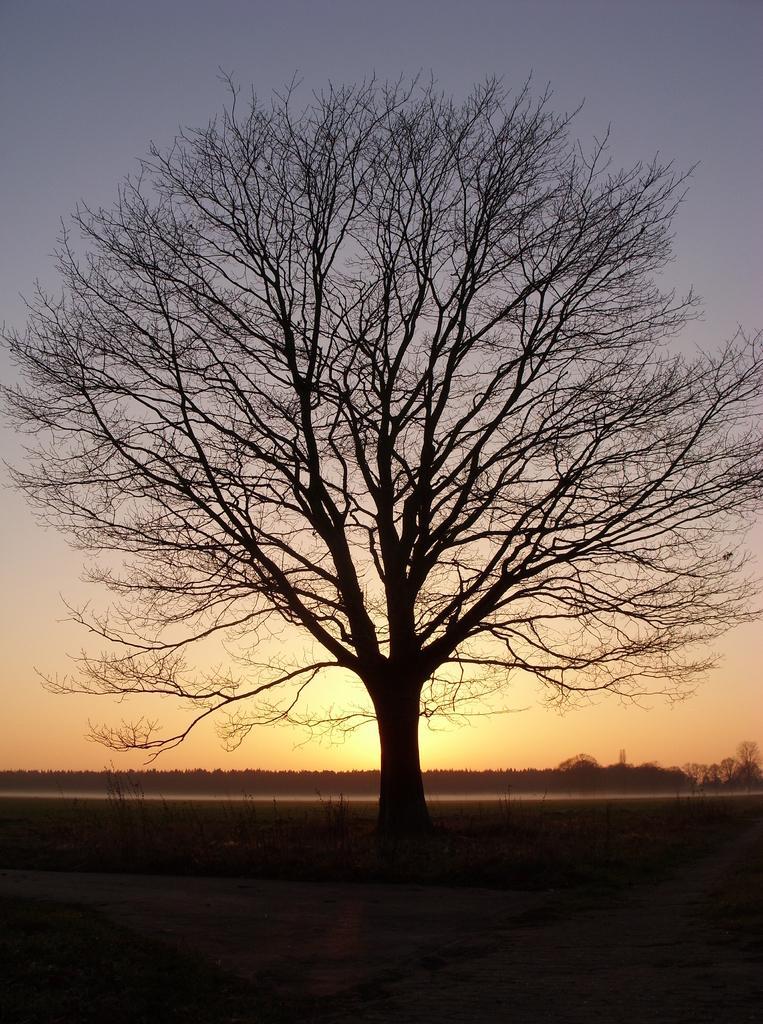Please provide a concise description of this image. This is an outside view. In this image I can see a tree. In the background there are many trees. At the top of the image I can see the sky. 